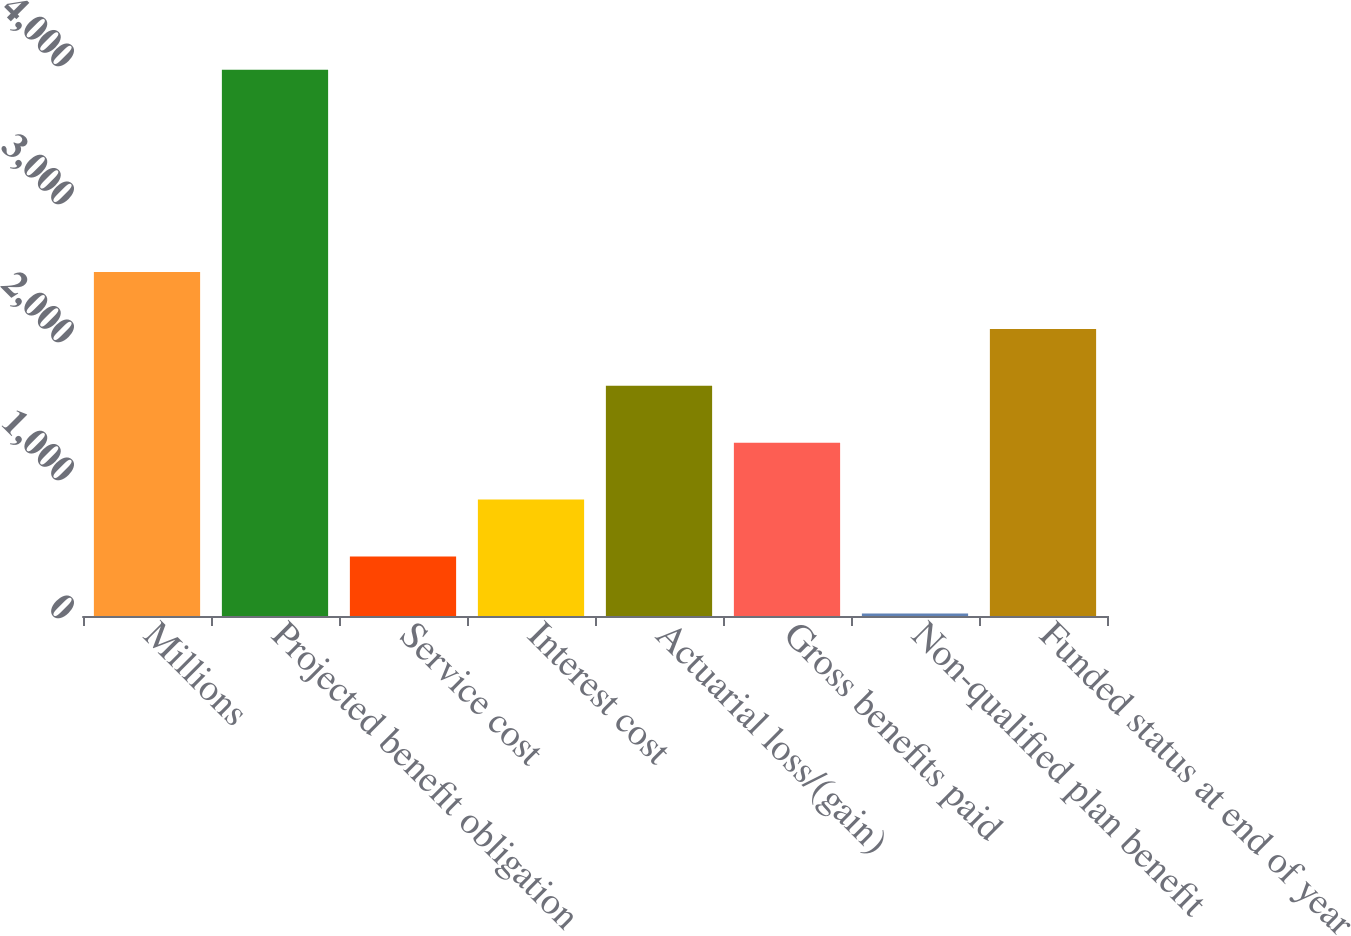Convert chart to OTSL. <chart><loc_0><loc_0><loc_500><loc_500><bar_chart><fcel>Millions<fcel>Projected benefit obligation<fcel>Service cost<fcel>Interest cost<fcel>Actuarial loss/(gain)<fcel>Gross benefits paid<fcel>Non-qualified plan benefit<fcel>Funded status at end of year<nl><fcel>2492.8<fcel>3958<fcel>431.3<fcel>843.6<fcel>1668.2<fcel>1255.9<fcel>19<fcel>2080.5<nl></chart> 